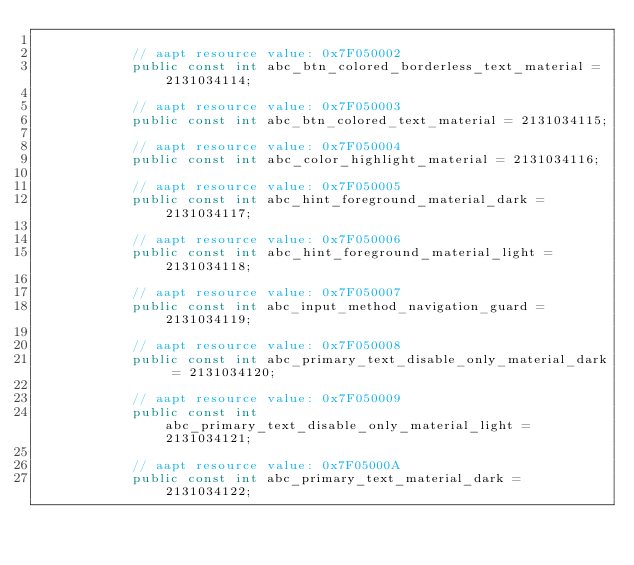Convert code to text. <code><loc_0><loc_0><loc_500><loc_500><_C#_>			
			// aapt resource value: 0x7F050002
			public const int abc_btn_colored_borderless_text_material = 2131034114;
			
			// aapt resource value: 0x7F050003
			public const int abc_btn_colored_text_material = 2131034115;
			
			// aapt resource value: 0x7F050004
			public const int abc_color_highlight_material = 2131034116;
			
			// aapt resource value: 0x7F050005
			public const int abc_hint_foreground_material_dark = 2131034117;
			
			// aapt resource value: 0x7F050006
			public const int abc_hint_foreground_material_light = 2131034118;
			
			// aapt resource value: 0x7F050007
			public const int abc_input_method_navigation_guard = 2131034119;
			
			// aapt resource value: 0x7F050008
			public const int abc_primary_text_disable_only_material_dark = 2131034120;
			
			// aapt resource value: 0x7F050009
			public const int abc_primary_text_disable_only_material_light = 2131034121;
			
			// aapt resource value: 0x7F05000A
			public const int abc_primary_text_material_dark = 2131034122;
			</code> 